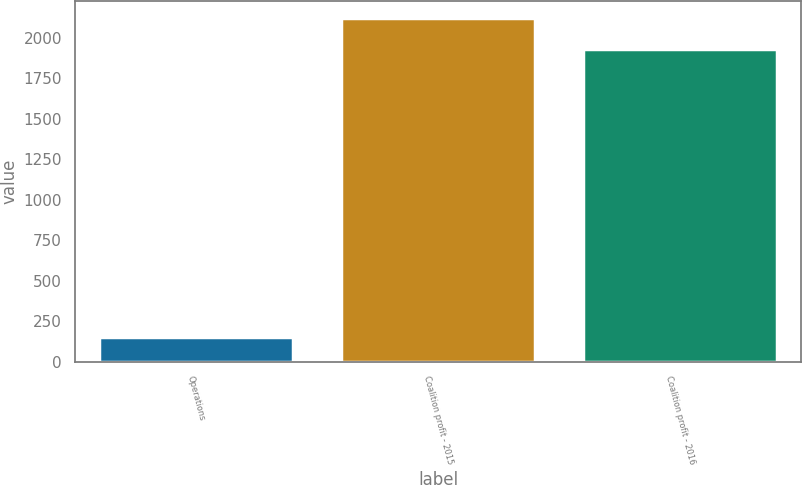<chart> <loc_0><loc_0><loc_500><loc_500><bar_chart><fcel>Operations<fcel>Coalition profit - 2015<fcel>Coalition profit - 2016<nl><fcel>154.9<fcel>2120.12<fcel>1930.2<nl></chart> 